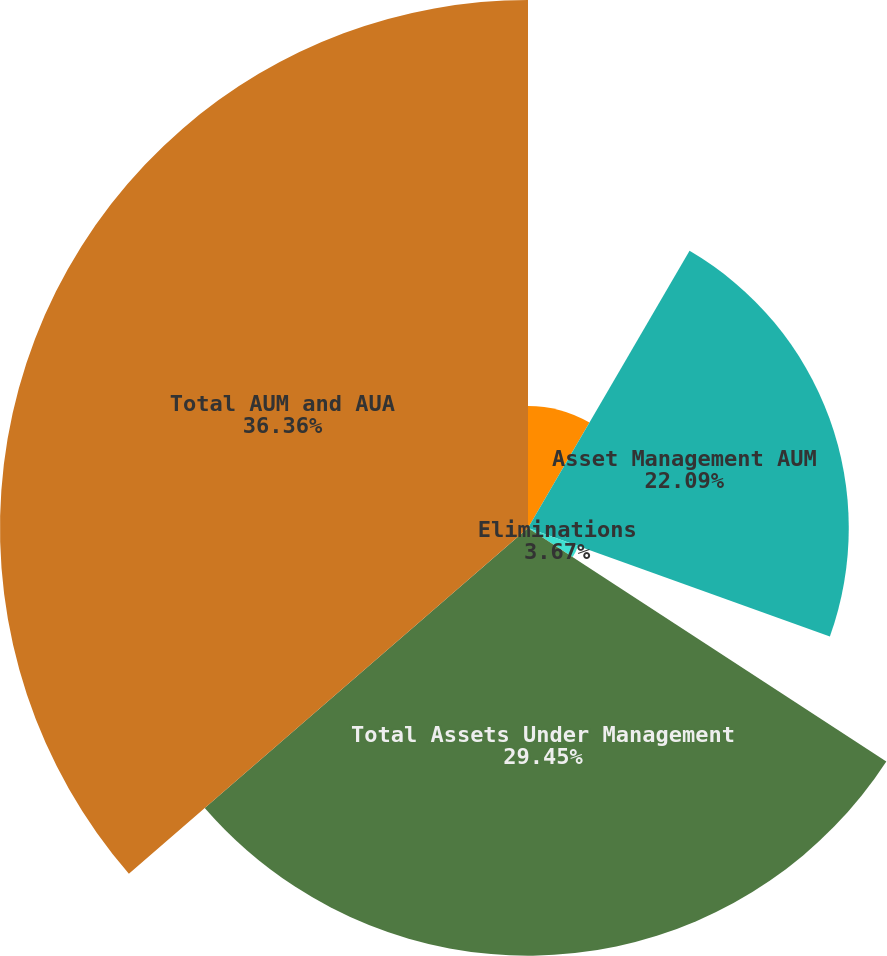<chart> <loc_0><loc_0><loc_500><loc_500><pie_chart><fcel>Advice & Wealth Management AUM<fcel>Asset Management AUM<fcel>Corporate & Other AUM<fcel>Eliminations<fcel>Total Assets Under Management<fcel>Total AUM and AUA<nl><fcel>8.4%<fcel>22.09%<fcel>0.03%<fcel>3.67%<fcel>29.45%<fcel>36.36%<nl></chart> 